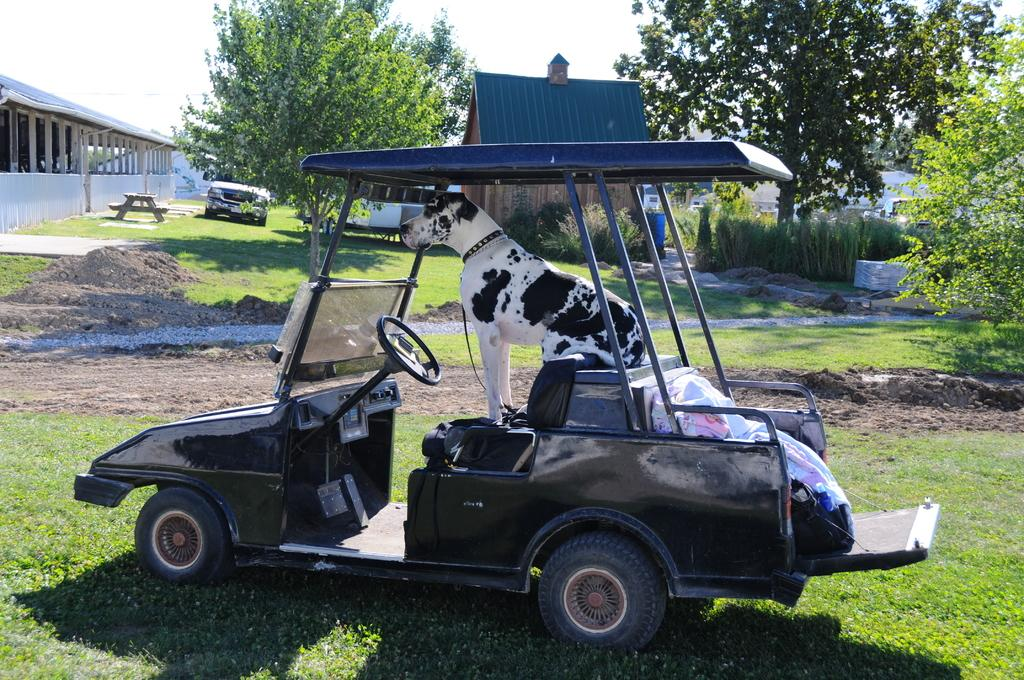What is the main feature of the image? There is an open space in the image. What can be seen in the open space? There is a vehicle in the image, and a dog is on top of the vehicle. Are there any other vehicles in the image? Yes, there is another vehicle in the image. What can be seen in the background of the image? There is a hut, trees, and the sky visible in the background of the image. There is also a table in the background. What is the aftermath of the bomb explosion in the image? There is no mention of a bomb explosion in the image, and therefore no aftermath can be observed. 